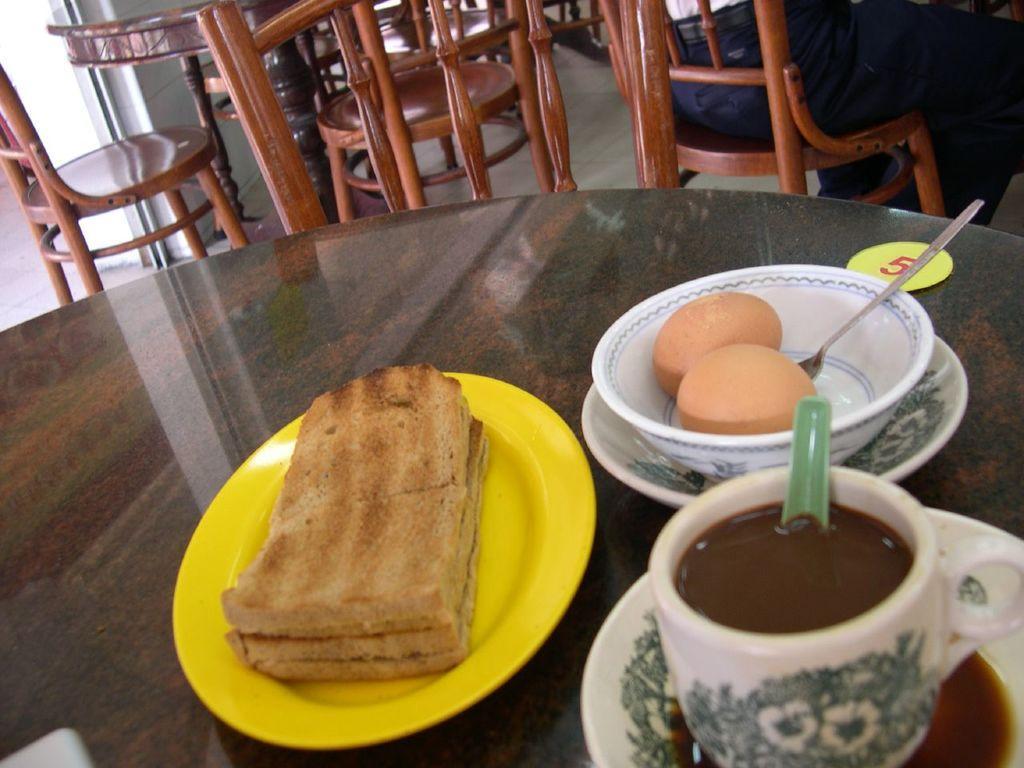Describe this image in one or two sentences. In this picture there is food on the plate and in the bowl and there is a plate and there is a cup and there are saucers and there is a bowl, spoon on the table. At the back there is a person sitting on the chair and there are tables and chairs. At the bottom there is a floor. 